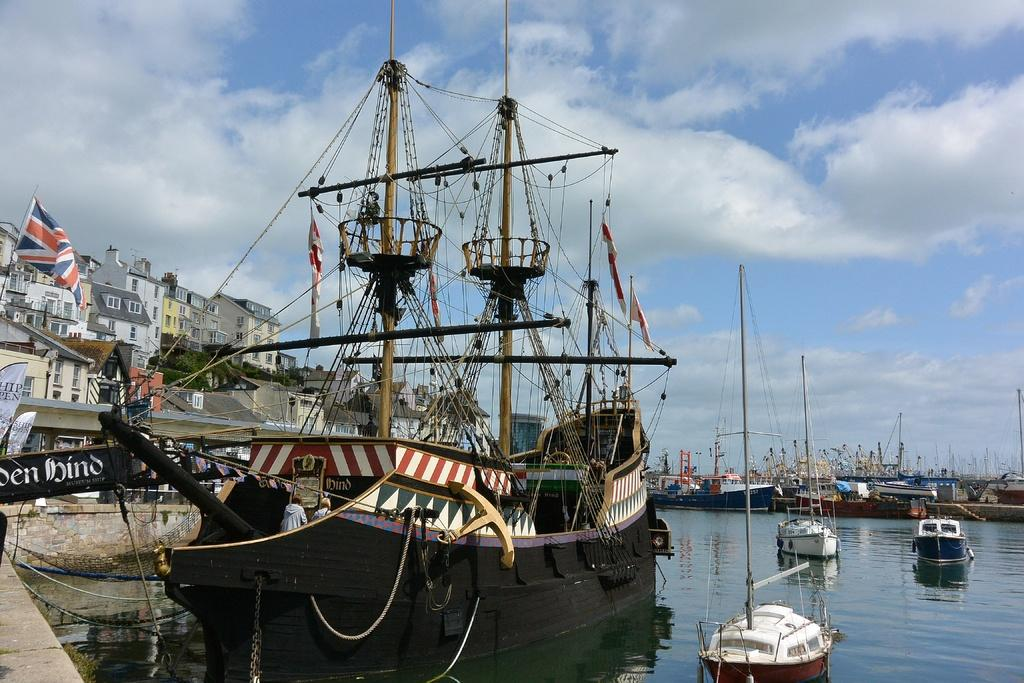What types of watercraft are in the image? There are ships and boats in the water. What can be seen on the left side of the image? There are buildings and a flag on the left side of the image. How would you describe the sky in the image? The sky is cloudy. What type of tin can be seen in the scene? There is no tin present in the image; it features ships, boats, buildings, a flag, and a cloudy sky. Can you describe the bat that is flying in the scene? There are no bats present in the image; it features ships, boats, buildings, a flag, and a cloudy sky. 